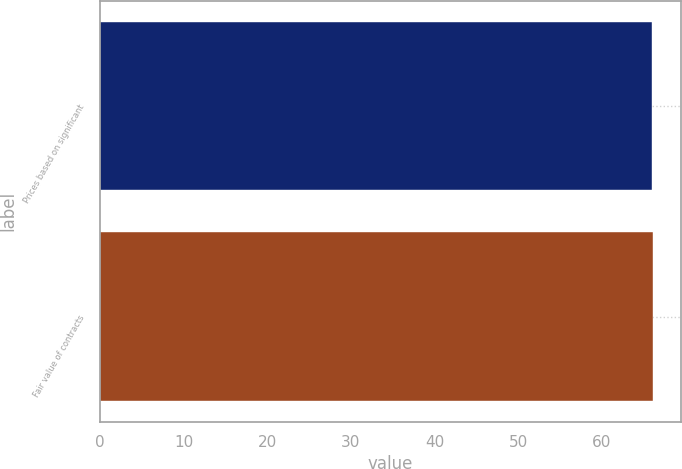<chart> <loc_0><loc_0><loc_500><loc_500><bar_chart><fcel>Prices based on significant<fcel>Fair value of contracts<nl><fcel>66<fcel>66.1<nl></chart> 